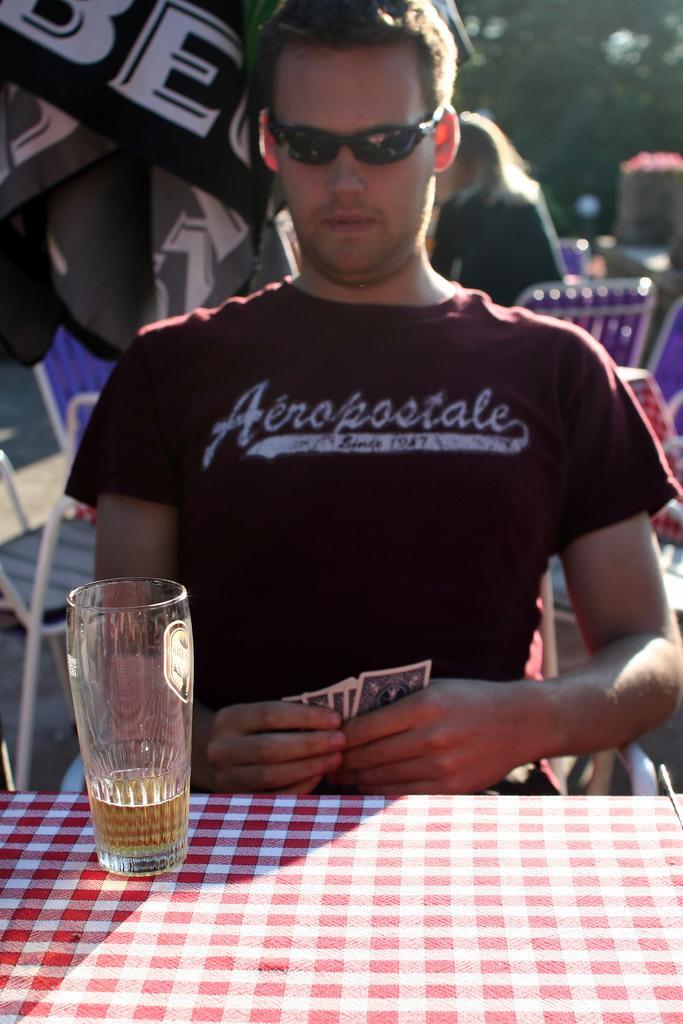Can you describe this image briefly? In this image, there is a table which is covered by a red cloth, there is a glass on the table which contains wine and there is a man sitting on the chair he is having some cards in his hands, In the background there are some persons sitting on the chairs and there are some trees which are in green color. 